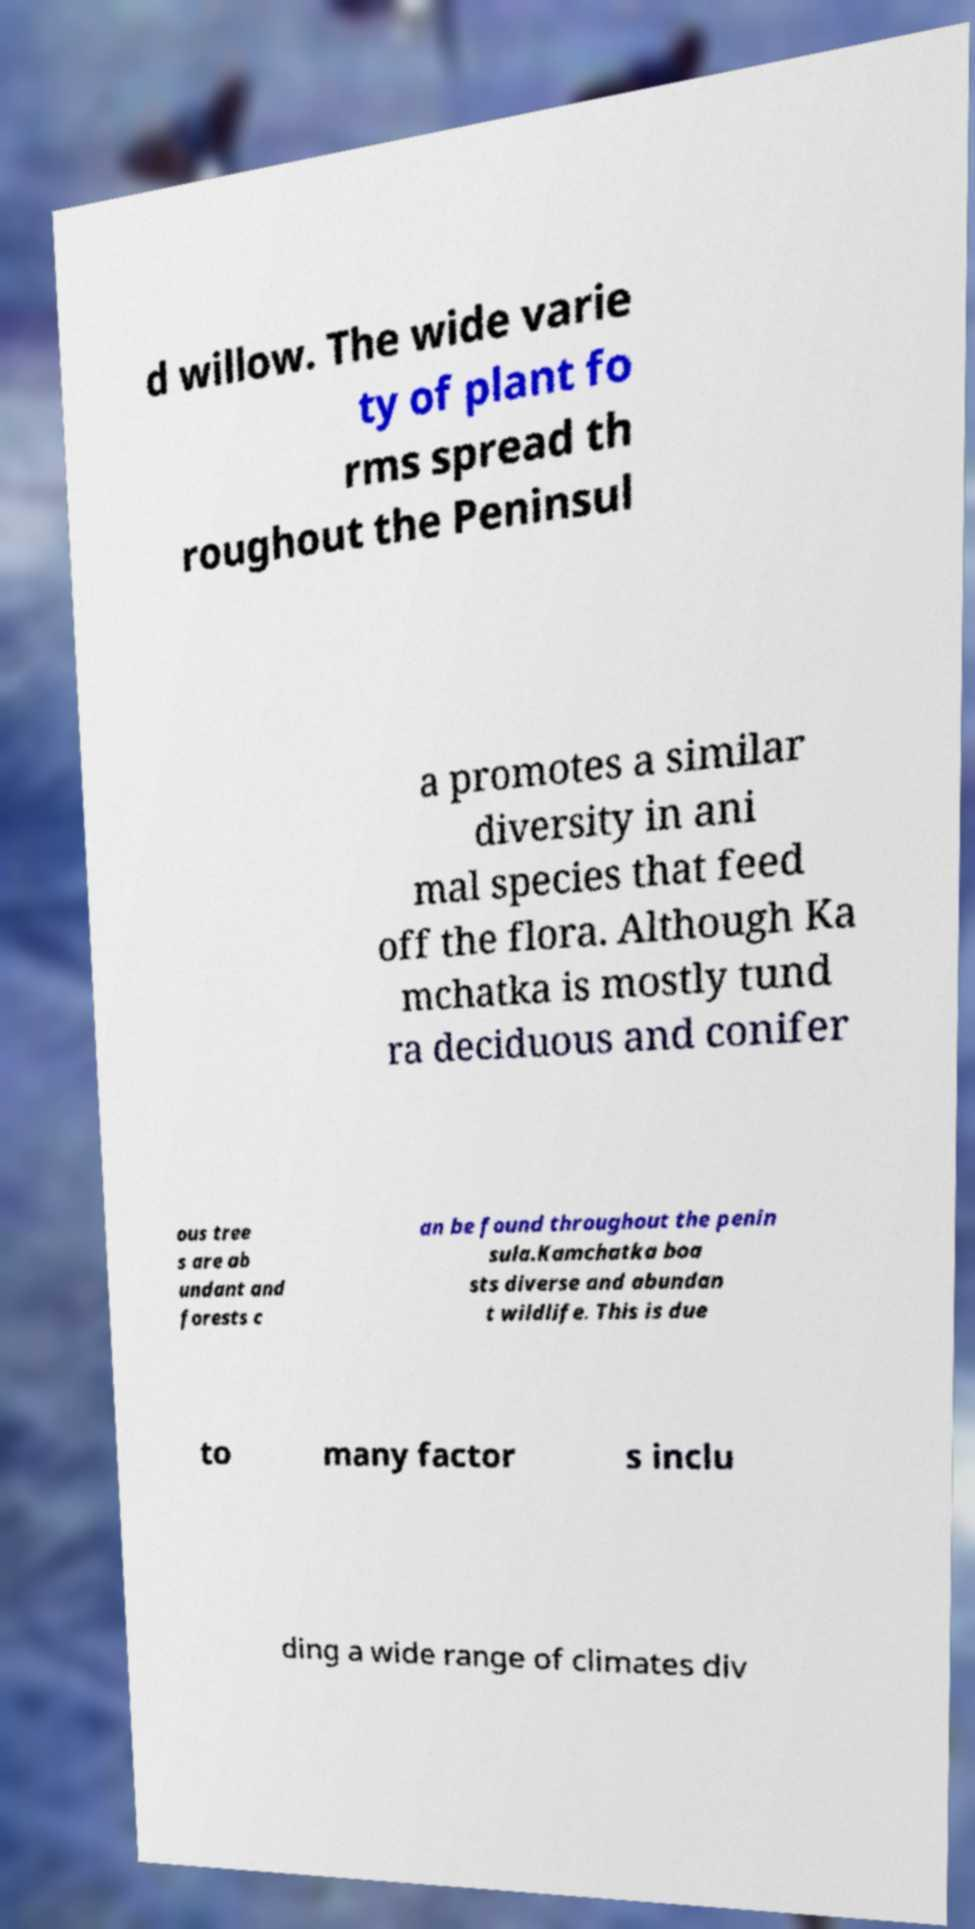I need the written content from this picture converted into text. Can you do that? d willow. The wide varie ty of plant fo rms spread th roughout the Peninsul a promotes a similar diversity in ani mal species that feed off the flora. Although Ka mchatka is mostly tund ra deciduous and conifer ous tree s are ab undant and forests c an be found throughout the penin sula.Kamchatka boa sts diverse and abundan t wildlife. This is due to many factor s inclu ding a wide range of climates div 